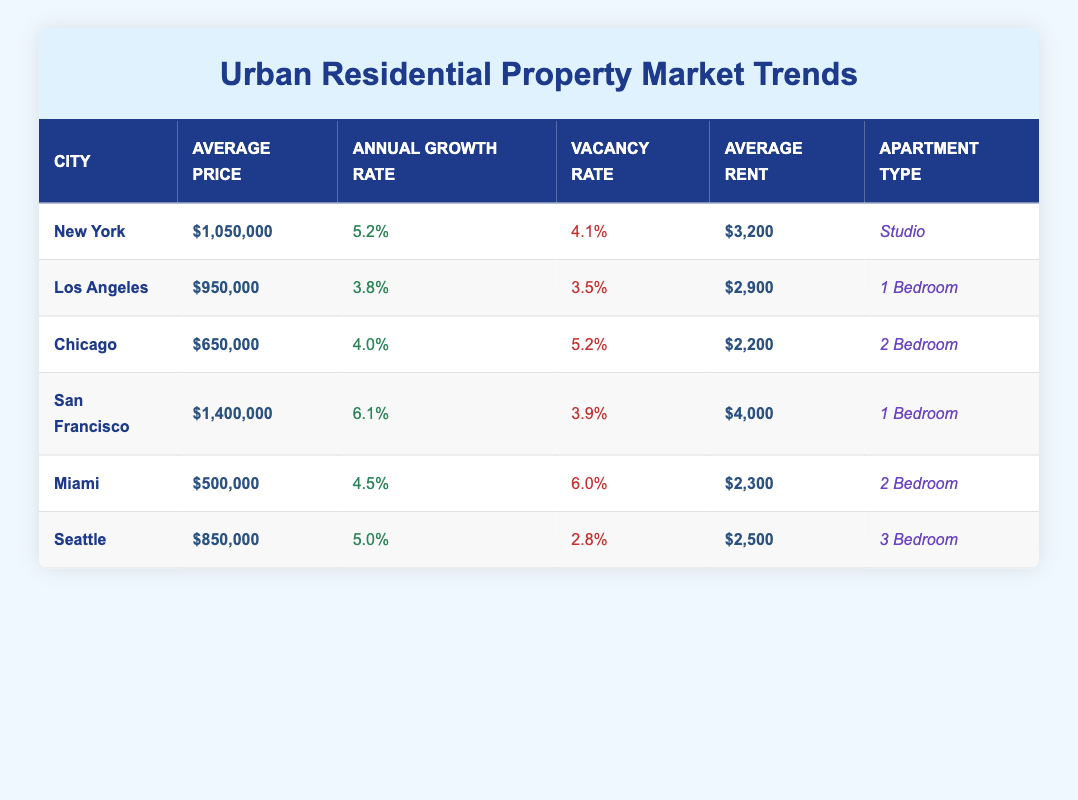What is the average price of residential properties in San Francisco? The average price listed in the table for San Francisco is $1,400,000.
Answer: $1,400,000 What is the annual growth rate for properties in Chicago? The table states that the annual growth rate for properties in Chicago is 4.0%.
Answer: 4.0% Which city has the highest average rent for residential properties? The average rent for residential properties in San Francisco is $4,000, which is the highest when compared to the other cities listed.
Answer: San Francisco What is the difference in vacancy rates between Miami and Seattle? The vacancy rate for Miami is 6.0%, and for Seattle, it is 2.8%. The difference is calculated as 6.0% - 2.8% = 3.2%.
Answer: 3.2% Is the average price of a 3-bedroom apartment in Seattle lower than the average rent of a 2-bedroom apartment in Chicago? The average price of a 3-bedroom apartment in Seattle is $850,000, while the average rent of a 2-bedroom apartment in Chicago is $2,200. Therefore, yes, $850,000 is lower.
Answer: No What is the average annual growth rate for New York and San Francisco combined? Adding the annual growth rates of New York (5.2%) and San Francisco (6.1%) gives 5.2% + 6.1% = 11.3%. To find the average, divide this by 2, resulting in 11.3% / 2 = 5.65%.
Answer: 5.65% Which city has a lower average rent, Seattle or Miami? The average rent in Seattle is $2,500, while in Miami it is $2,300. Since $2,300 is lower than $2,500, Miami has a lower average rent.
Answer: Miami What percentage of annual growth is higher: that of New York or Los Angeles? New York has an annual growth rate of 5.2%, while Los Angeles has 3.8%. Comparing these rates shows that New York's growth rate is higher.
Answer: Yes Which city has the lowest average price and what is that price? The city with the lowest average price listed in the table is Miami, with an average price of $500,000.
Answer: Miami; $500,000 